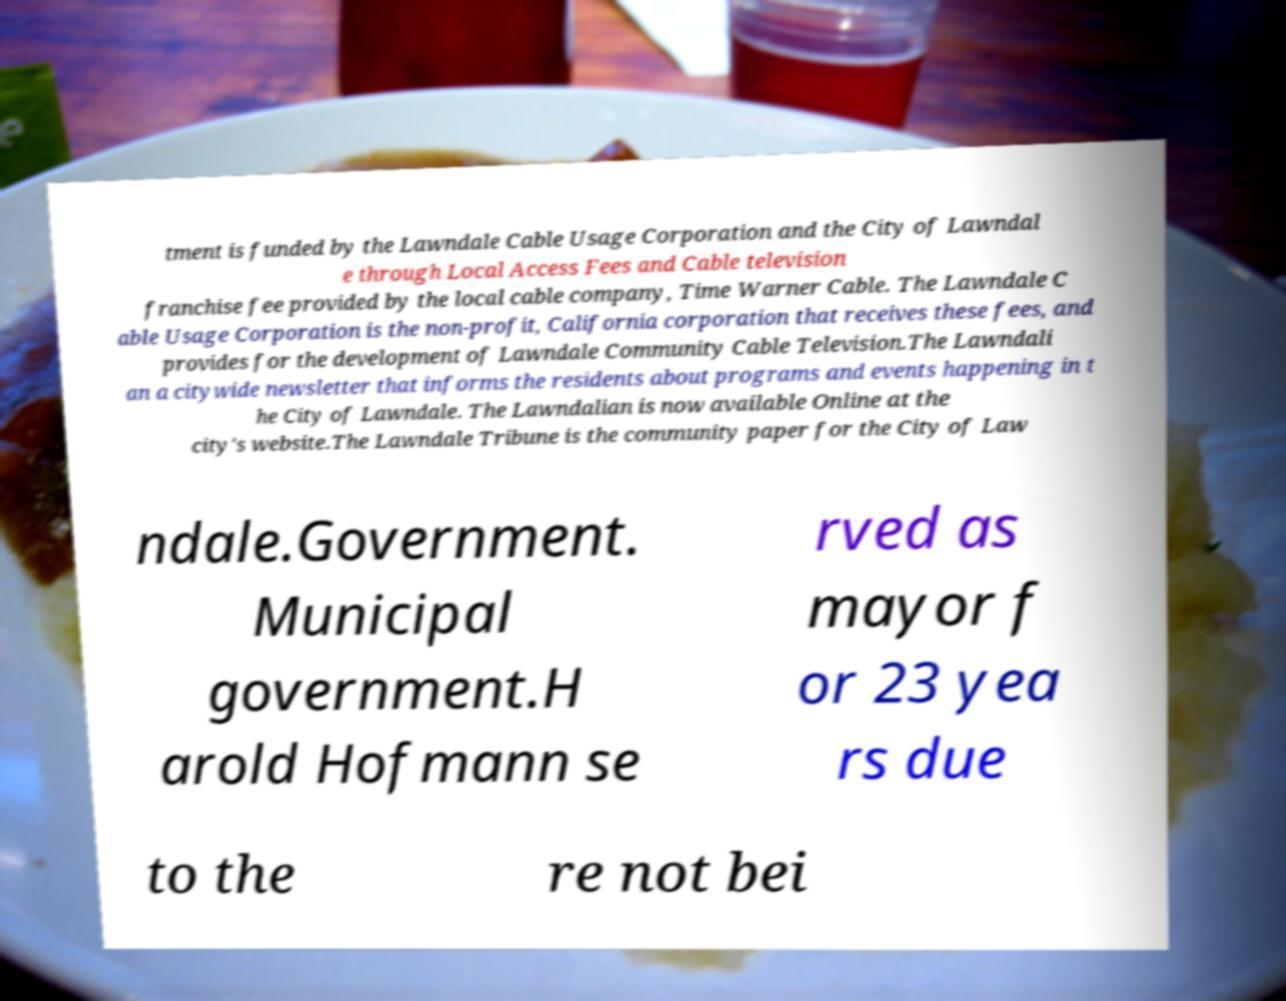I need the written content from this picture converted into text. Can you do that? tment is funded by the Lawndale Cable Usage Corporation and the City of Lawndal e through Local Access Fees and Cable television franchise fee provided by the local cable company, Time Warner Cable. The Lawndale C able Usage Corporation is the non-profit, California corporation that receives these fees, and provides for the development of Lawndale Community Cable Television.The Lawndali an a citywide newsletter that informs the residents about programs and events happening in t he City of Lawndale. The Lawndalian is now available Online at the city's website.The Lawndale Tribune is the community paper for the City of Law ndale.Government. Municipal government.H arold Hofmann se rved as mayor f or 23 yea rs due to the re not bei 